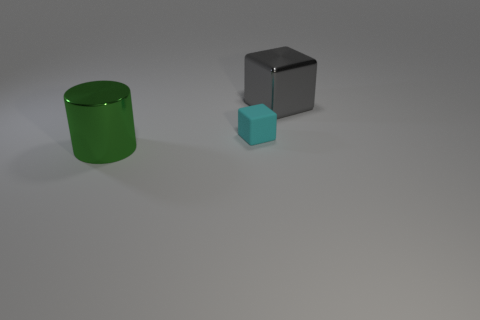Add 3 tiny green metallic things. How many objects exist? 6 Subtract all cubes. How many objects are left? 1 Add 3 purple spheres. How many purple spheres exist? 3 Subtract 0 blue cubes. How many objects are left? 3 Subtract all gray metallic cubes. Subtract all large gray blocks. How many objects are left? 1 Add 3 cubes. How many cubes are left? 5 